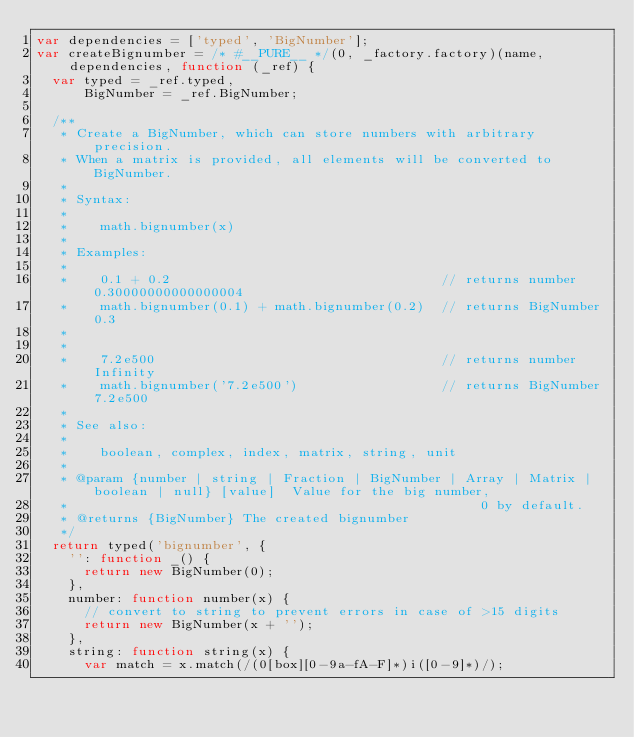Convert code to text. <code><loc_0><loc_0><loc_500><loc_500><_JavaScript_>var dependencies = ['typed', 'BigNumber'];
var createBignumber = /* #__PURE__ */(0, _factory.factory)(name, dependencies, function (_ref) {
  var typed = _ref.typed,
      BigNumber = _ref.BigNumber;

  /**
   * Create a BigNumber, which can store numbers with arbitrary precision.
   * When a matrix is provided, all elements will be converted to BigNumber.
   *
   * Syntax:
   *
   *    math.bignumber(x)
   *
   * Examples:
   *
   *    0.1 + 0.2                                  // returns number 0.30000000000000004
   *    math.bignumber(0.1) + math.bignumber(0.2)  // returns BigNumber 0.3
   *
   *
   *    7.2e500                                    // returns number Infinity
   *    math.bignumber('7.2e500')                  // returns BigNumber 7.2e500
   *
   * See also:
   *
   *    boolean, complex, index, matrix, string, unit
   *
   * @param {number | string | Fraction | BigNumber | Array | Matrix | boolean | null} [value]  Value for the big number,
   *                                                    0 by default.
   * @returns {BigNumber} The created bignumber
   */
  return typed('bignumber', {
    '': function _() {
      return new BigNumber(0);
    },
    number: function number(x) {
      // convert to string to prevent errors in case of >15 digits
      return new BigNumber(x + '');
    },
    string: function string(x) {
      var match = x.match(/(0[box][0-9a-fA-F]*)i([0-9]*)/);
</code> 